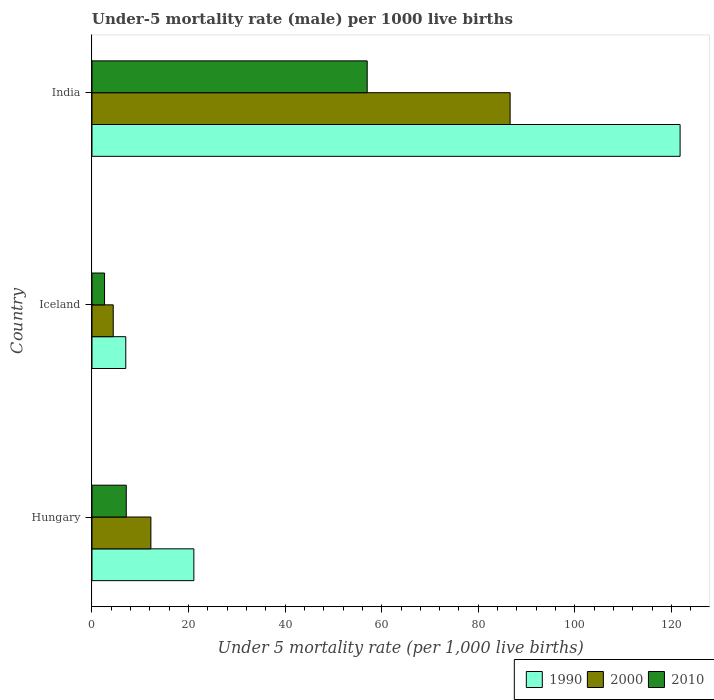How many groups of bars are there?
Provide a succinct answer. 3. Are the number of bars per tick equal to the number of legend labels?
Ensure brevity in your answer.  Yes. Are the number of bars on each tick of the Y-axis equal?
Your response must be concise. Yes. How many bars are there on the 2nd tick from the top?
Your response must be concise. 3. How many bars are there on the 3rd tick from the bottom?
Keep it short and to the point. 3. What is the label of the 3rd group of bars from the top?
Offer a terse response. Hungary. In how many cases, is the number of bars for a given country not equal to the number of legend labels?
Offer a terse response. 0. What is the under-five mortality rate in 2010 in Hungary?
Make the answer very short. 7.1. What is the total under-five mortality rate in 2000 in the graph?
Give a very brief answer. 103.2. What is the difference between the under-five mortality rate in 2010 in Iceland and that in India?
Offer a terse response. -54.4. What is the difference between the under-five mortality rate in 2010 in India and the under-five mortality rate in 1990 in Hungary?
Keep it short and to the point. 35.9. What is the average under-five mortality rate in 2000 per country?
Provide a short and direct response. 34.4. What is the difference between the under-five mortality rate in 2010 and under-five mortality rate in 1990 in India?
Make the answer very short. -64.8. What is the ratio of the under-five mortality rate in 1990 in Hungary to that in Iceland?
Keep it short and to the point. 3.01. Is the under-five mortality rate in 2010 in Hungary less than that in India?
Provide a short and direct response. Yes. Is the difference between the under-five mortality rate in 2010 in Hungary and India greater than the difference between the under-five mortality rate in 1990 in Hungary and India?
Give a very brief answer. Yes. What is the difference between the highest and the second highest under-five mortality rate in 2000?
Make the answer very short. 74.4. What is the difference between the highest and the lowest under-five mortality rate in 1990?
Keep it short and to the point. 114.8. Is the sum of the under-five mortality rate in 2010 in Iceland and India greater than the maximum under-five mortality rate in 1990 across all countries?
Your answer should be compact. No. What does the 3rd bar from the top in Hungary represents?
Ensure brevity in your answer.  1990. How many bars are there?
Offer a very short reply. 9. What is the difference between two consecutive major ticks on the X-axis?
Ensure brevity in your answer.  20. Does the graph contain grids?
Ensure brevity in your answer.  No. How many legend labels are there?
Offer a terse response. 3. What is the title of the graph?
Offer a terse response. Under-5 mortality rate (male) per 1000 live births. What is the label or title of the X-axis?
Your response must be concise. Under 5 mortality rate (per 1,0 live births). What is the label or title of the Y-axis?
Provide a succinct answer. Country. What is the Under 5 mortality rate (per 1,000 live births) of 1990 in Hungary?
Offer a very short reply. 21.1. What is the Under 5 mortality rate (per 1,000 live births) of 2010 in Iceland?
Your answer should be compact. 2.6. What is the Under 5 mortality rate (per 1,000 live births) in 1990 in India?
Provide a short and direct response. 121.8. What is the Under 5 mortality rate (per 1,000 live births) in 2000 in India?
Offer a terse response. 86.6. Across all countries, what is the maximum Under 5 mortality rate (per 1,000 live births) of 1990?
Provide a succinct answer. 121.8. Across all countries, what is the maximum Under 5 mortality rate (per 1,000 live births) of 2000?
Your answer should be compact. 86.6. Across all countries, what is the maximum Under 5 mortality rate (per 1,000 live births) of 2010?
Give a very brief answer. 57. Across all countries, what is the minimum Under 5 mortality rate (per 1,000 live births) in 1990?
Offer a terse response. 7. Across all countries, what is the minimum Under 5 mortality rate (per 1,000 live births) in 2010?
Provide a succinct answer. 2.6. What is the total Under 5 mortality rate (per 1,000 live births) of 1990 in the graph?
Provide a short and direct response. 149.9. What is the total Under 5 mortality rate (per 1,000 live births) of 2000 in the graph?
Keep it short and to the point. 103.2. What is the total Under 5 mortality rate (per 1,000 live births) in 2010 in the graph?
Your answer should be very brief. 66.7. What is the difference between the Under 5 mortality rate (per 1,000 live births) of 1990 in Hungary and that in Iceland?
Your answer should be compact. 14.1. What is the difference between the Under 5 mortality rate (per 1,000 live births) in 2000 in Hungary and that in Iceland?
Your answer should be very brief. 7.8. What is the difference between the Under 5 mortality rate (per 1,000 live births) of 1990 in Hungary and that in India?
Provide a short and direct response. -100.7. What is the difference between the Under 5 mortality rate (per 1,000 live births) in 2000 in Hungary and that in India?
Provide a succinct answer. -74.4. What is the difference between the Under 5 mortality rate (per 1,000 live births) in 2010 in Hungary and that in India?
Ensure brevity in your answer.  -49.9. What is the difference between the Under 5 mortality rate (per 1,000 live births) of 1990 in Iceland and that in India?
Make the answer very short. -114.8. What is the difference between the Under 5 mortality rate (per 1,000 live births) of 2000 in Iceland and that in India?
Your answer should be very brief. -82.2. What is the difference between the Under 5 mortality rate (per 1,000 live births) of 2010 in Iceland and that in India?
Keep it short and to the point. -54.4. What is the difference between the Under 5 mortality rate (per 1,000 live births) of 2000 in Hungary and the Under 5 mortality rate (per 1,000 live births) of 2010 in Iceland?
Your response must be concise. 9.6. What is the difference between the Under 5 mortality rate (per 1,000 live births) of 1990 in Hungary and the Under 5 mortality rate (per 1,000 live births) of 2000 in India?
Offer a terse response. -65.5. What is the difference between the Under 5 mortality rate (per 1,000 live births) of 1990 in Hungary and the Under 5 mortality rate (per 1,000 live births) of 2010 in India?
Your response must be concise. -35.9. What is the difference between the Under 5 mortality rate (per 1,000 live births) of 2000 in Hungary and the Under 5 mortality rate (per 1,000 live births) of 2010 in India?
Keep it short and to the point. -44.8. What is the difference between the Under 5 mortality rate (per 1,000 live births) of 1990 in Iceland and the Under 5 mortality rate (per 1,000 live births) of 2000 in India?
Offer a terse response. -79.6. What is the difference between the Under 5 mortality rate (per 1,000 live births) in 1990 in Iceland and the Under 5 mortality rate (per 1,000 live births) in 2010 in India?
Your answer should be very brief. -50. What is the difference between the Under 5 mortality rate (per 1,000 live births) in 2000 in Iceland and the Under 5 mortality rate (per 1,000 live births) in 2010 in India?
Make the answer very short. -52.6. What is the average Under 5 mortality rate (per 1,000 live births) of 1990 per country?
Provide a succinct answer. 49.97. What is the average Under 5 mortality rate (per 1,000 live births) in 2000 per country?
Provide a short and direct response. 34.4. What is the average Under 5 mortality rate (per 1,000 live births) of 2010 per country?
Keep it short and to the point. 22.23. What is the difference between the Under 5 mortality rate (per 1,000 live births) in 1990 and Under 5 mortality rate (per 1,000 live births) in 2000 in Hungary?
Give a very brief answer. 8.9. What is the difference between the Under 5 mortality rate (per 1,000 live births) of 1990 and Under 5 mortality rate (per 1,000 live births) of 2010 in Hungary?
Give a very brief answer. 14. What is the difference between the Under 5 mortality rate (per 1,000 live births) in 1990 and Under 5 mortality rate (per 1,000 live births) in 2000 in Iceland?
Your response must be concise. 2.6. What is the difference between the Under 5 mortality rate (per 1,000 live births) of 2000 and Under 5 mortality rate (per 1,000 live births) of 2010 in Iceland?
Provide a succinct answer. 1.8. What is the difference between the Under 5 mortality rate (per 1,000 live births) in 1990 and Under 5 mortality rate (per 1,000 live births) in 2000 in India?
Give a very brief answer. 35.2. What is the difference between the Under 5 mortality rate (per 1,000 live births) of 1990 and Under 5 mortality rate (per 1,000 live births) of 2010 in India?
Your answer should be very brief. 64.8. What is the difference between the Under 5 mortality rate (per 1,000 live births) in 2000 and Under 5 mortality rate (per 1,000 live births) in 2010 in India?
Provide a short and direct response. 29.6. What is the ratio of the Under 5 mortality rate (per 1,000 live births) in 1990 in Hungary to that in Iceland?
Provide a short and direct response. 3.01. What is the ratio of the Under 5 mortality rate (per 1,000 live births) of 2000 in Hungary to that in Iceland?
Your response must be concise. 2.77. What is the ratio of the Under 5 mortality rate (per 1,000 live births) of 2010 in Hungary to that in Iceland?
Your answer should be compact. 2.73. What is the ratio of the Under 5 mortality rate (per 1,000 live births) in 1990 in Hungary to that in India?
Your answer should be very brief. 0.17. What is the ratio of the Under 5 mortality rate (per 1,000 live births) in 2000 in Hungary to that in India?
Your answer should be very brief. 0.14. What is the ratio of the Under 5 mortality rate (per 1,000 live births) of 2010 in Hungary to that in India?
Give a very brief answer. 0.12. What is the ratio of the Under 5 mortality rate (per 1,000 live births) in 1990 in Iceland to that in India?
Offer a terse response. 0.06. What is the ratio of the Under 5 mortality rate (per 1,000 live births) in 2000 in Iceland to that in India?
Keep it short and to the point. 0.05. What is the ratio of the Under 5 mortality rate (per 1,000 live births) of 2010 in Iceland to that in India?
Provide a succinct answer. 0.05. What is the difference between the highest and the second highest Under 5 mortality rate (per 1,000 live births) of 1990?
Offer a very short reply. 100.7. What is the difference between the highest and the second highest Under 5 mortality rate (per 1,000 live births) of 2000?
Offer a terse response. 74.4. What is the difference between the highest and the second highest Under 5 mortality rate (per 1,000 live births) of 2010?
Ensure brevity in your answer.  49.9. What is the difference between the highest and the lowest Under 5 mortality rate (per 1,000 live births) of 1990?
Offer a very short reply. 114.8. What is the difference between the highest and the lowest Under 5 mortality rate (per 1,000 live births) of 2000?
Keep it short and to the point. 82.2. What is the difference between the highest and the lowest Under 5 mortality rate (per 1,000 live births) in 2010?
Ensure brevity in your answer.  54.4. 